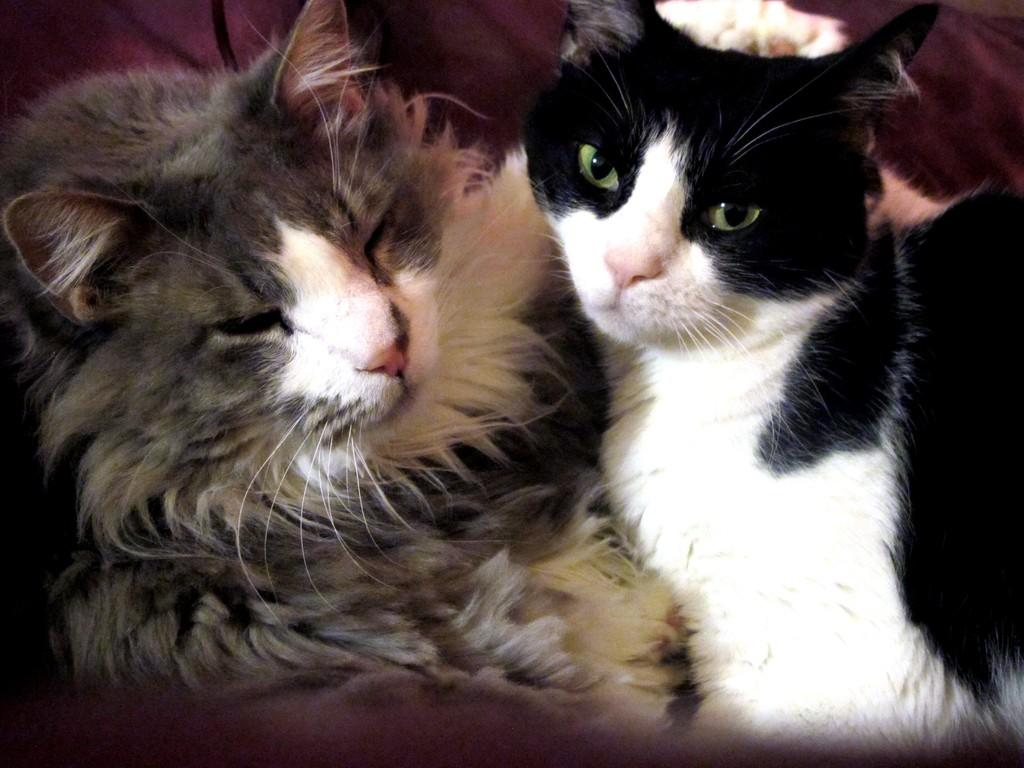How many cats are present in the image? There are two cats in the image. Can you describe the object in the background of the image? Unfortunately, the provided facts do not give any information about the object in the background. What type of cabbage is being used for pets to learn in the image? There is no cabbage or learning activity involving pets present in the image. 